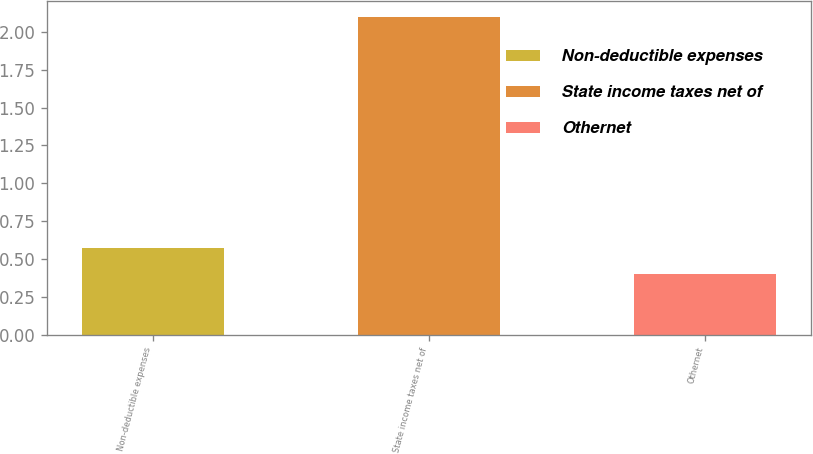<chart> <loc_0><loc_0><loc_500><loc_500><bar_chart><fcel>Non-deductible expenses<fcel>State income taxes net of<fcel>Othernet<nl><fcel>0.57<fcel>2.1<fcel>0.4<nl></chart> 